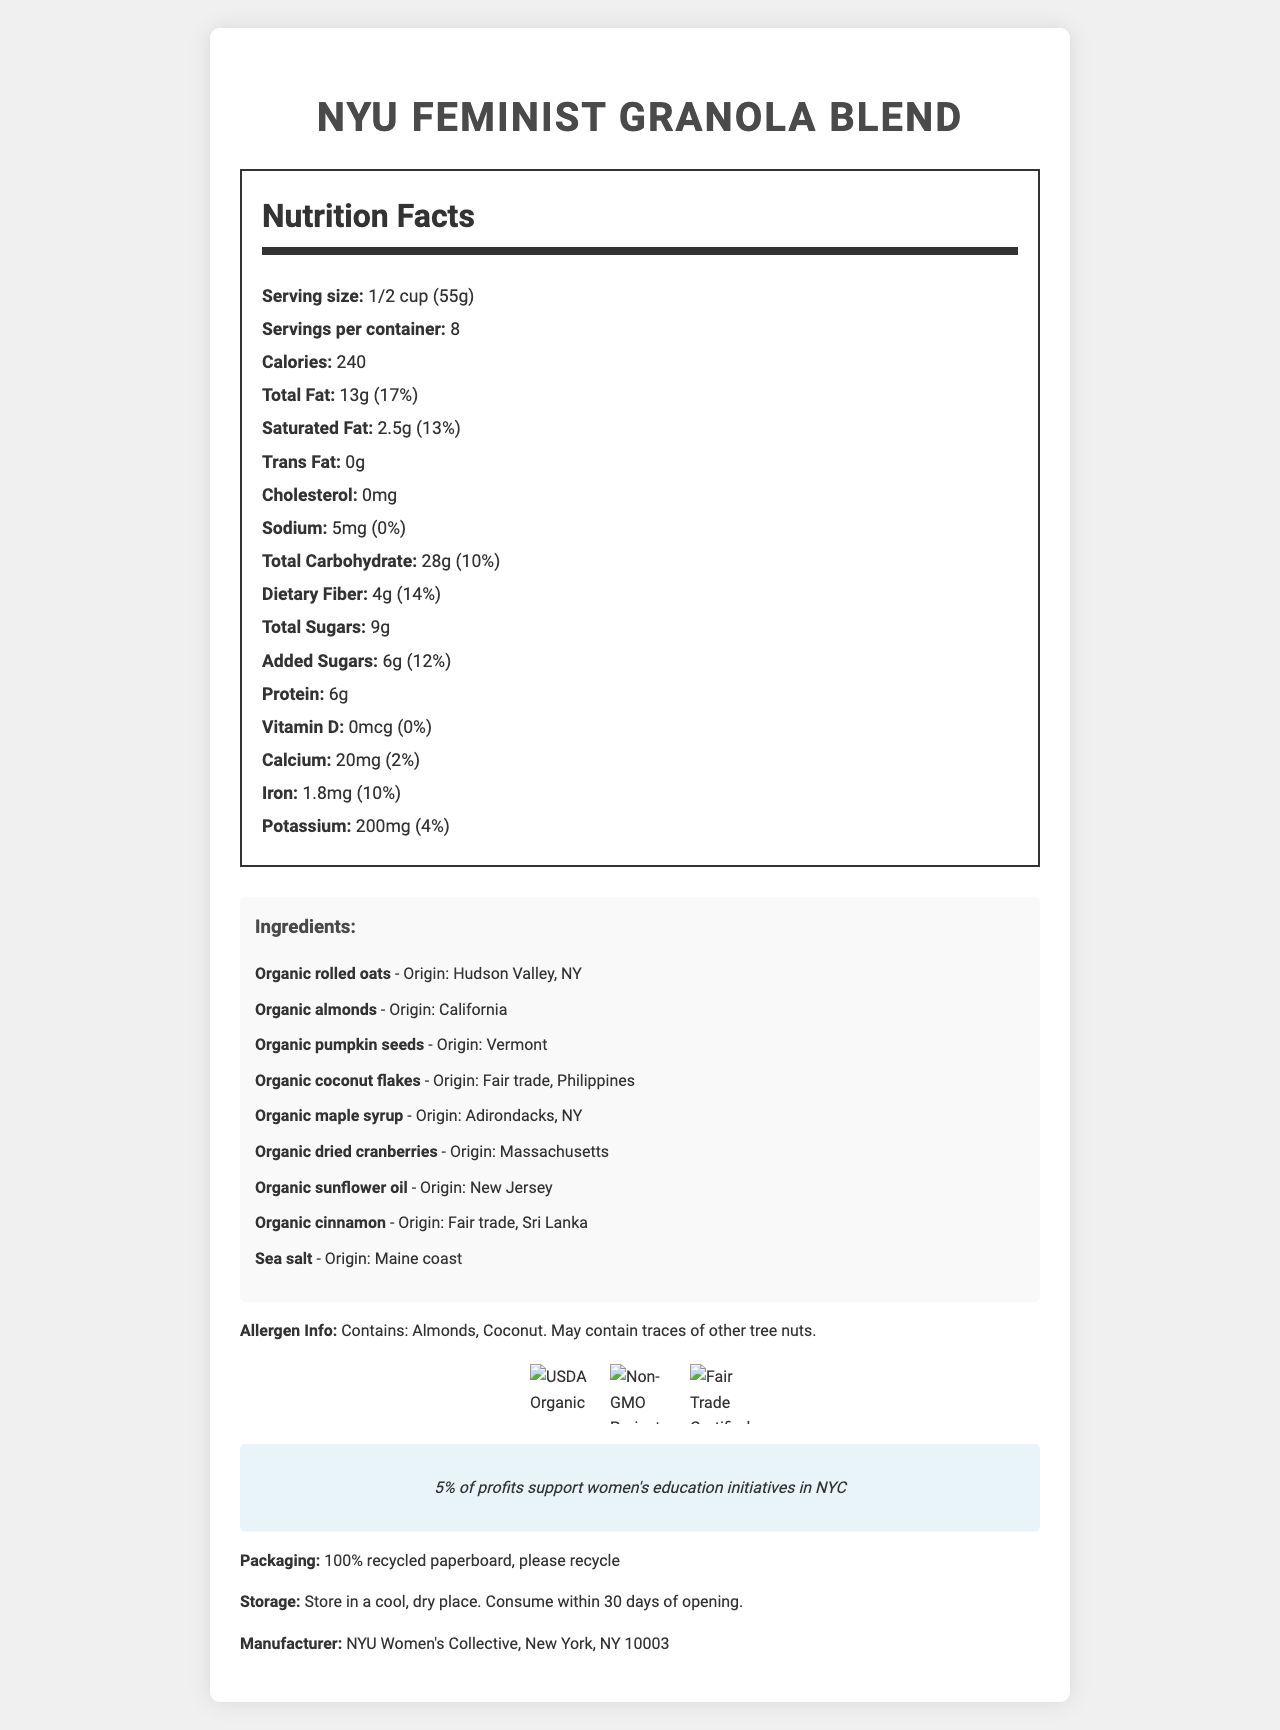What is the serving size of the NYU Feminist Granola Blend? The document lists the serving size as 1/2 cup (55g) right under the product name in the Nutrition Facts section.
Answer: 1/2 cup (55g) How many calories are there per serving? In the Nutrition Facts section, it mentions that each serving contains 240 calories.
Answer: 240 Which ingredient originates from the Hudson Valley, NY? The ingredient list specifies the origin of organic rolled oats as Hudson Valley, NY.
Answer: Organic rolled oats What percentage of the daily value of calcium does one serving contain? The document indicates the Calcium content as 20mg, which is 2% of the daily value.
Answer: 2% Does the NYU Feminist Granola Blend contain any cholesterol? The Nutrition Facts section states that the cholesterol content is 0mg.
Answer: No What is the protein content per serving? The Nutrition Facts section mentions that each serving contains 6g of protein.
Answer: 6g How many servings are there per container? The serving details specify that there are 8 servings per container.
Answer: 8 What is the total carbohydrate content per serving and its daily value percentage? The Nutrition Facts section shows that the total carbohydrate content is 28g, which is 10% of the daily value.
Answer: 28g, 10% Which ingredient is sourced through Fair Trade from the Philippines? The list of ingredients indicates that organic coconut flakes are sourced from Fair Trade Philippines.
Answer: Organic coconut flakes What is the amount and percentage of the daily value of dietary fiber per serving? The Nutrition Facts section lists dietary fiber as 4g per serving, which is 14% of the daily value.
Answer: 4g, 14% What certifications does the NYU Feminist Granola Blend have? The document lists these three certifications with their corresponding logos.
Answer: USDA Organic, Non-GMO Project Verified, Fair Trade Certified How should the granola be stored? The document advises to store the granola in a cool, dry place and consume it within 30 days of opening.
Answer: In a cool, dry place. Consume within 30 days of opening. What percentage of profits support women's education initiatives in NYC? The document includes a note that 5% of profits go towards supporting women's education initiatives in NYC.
Answer: 5% Who is the manufacturer of the NYU Feminist Granola Blend? The bottom of the document indicates that the manufacturer is the NYU Women's Collective.
Answer: NYU Women's Collective, New York, NY 10003 Which of the following ingredients may contain traces of other tree nuts? A. Organic rolled oats B. Organic almonds C. Organic sunflower oil The allergen info section specifies that the product contains almonds and may contain traces of other tree nuts, pointing directly to almonds.
Answer: B. Organic almonds How much vitamin D is in one serving? A. 0mcg B. 1mcg C. 2mcg D. 5mcg The Nutrition Facts section shows that the vitamin D content is 0mcg per serving.
Answer: A. 0mcg Is there any trans fat in the NYU Feminist Granola Blend? The Nutrition Facts section indicates that the trans fat content is 0g.
Answer: No Summarize the main points of the NYU Feminist Granola Blend document. The document provides detailed information about the nutrition, ingredients, certifications, social impact, and storage instructions for the NYU Feminist Granola Blend, highlighting its health benefits and social contributions.
Answer: The NYU Feminist Granola Blend is an organic granola product made by the NYU Women's Collective. It features locally-sourced, fair trade ingredients and supports women's education initiatives in NYC with 5% of its profits. The package comes with detailed nutrition facts, including 240 calories per serving, 13g of total fat, and 6g of protein. It is certified USDA Organic, Non-GMO, and Fair Trade. It contains almonds and coconut, and should be stored in a cool, dry place and consumed within 30 days of opening. What is the source of the sea salt used in the granola? The ingredient list specifies that sea salt is sourced from the Maine coast.
Answer: Maine coast How many grams of added sugars are there in a serving? The Nutrition Facts section shows that there are 6g of added sugars per serving.
Answer: 6g What inspired the creation of NYU Feminist Granola Blend? The document does not provide any information about the inspiration behind the creation of the product.
Answer: Cannot be determined 